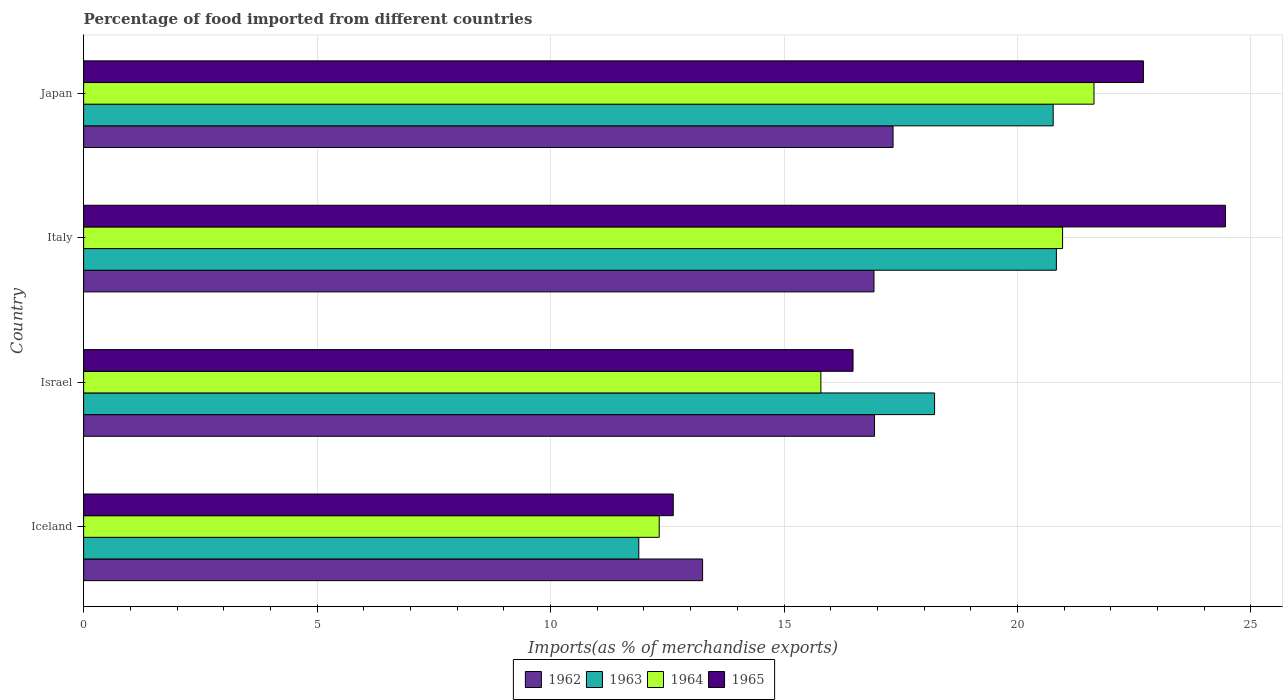How many different coloured bars are there?
Your answer should be compact. 4. How many groups of bars are there?
Provide a short and direct response. 4. Are the number of bars on each tick of the Y-axis equal?
Keep it short and to the point. Yes. How many bars are there on the 2nd tick from the top?
Your response must be concise. 4. How many bars are there on the 3rd tick from the bottom?
Give a very brief answer. 4. What is the percentage of imports to different countries in 1962 in Japan?
Provide a short and direct response. 17.34. Across all countries, what is the maximum percentage of imports to different countries in 1964?
Provide a short and direct response. 21.64. Across all countries, what is the minimum percentage of imports to different countries in 1965?
Offer a very short reply. 12.63. In which country was the percentage of imports to different countries in 1963 maximum?
Your response must be concise. Italy. What is the total percentage of imports to different countries in 1963 in the graph?
Your answer should be very brief. 71.71. What is the difference between the percentage of imports to different countries in 1963 in Italy and that in Japan?
Your response must be concise. 0.07. What is the difference between the percentage of imports to different countries in 1962 in Italy and the percentage of imports to different countries in 1963 in Iceland?
Your response must be concise. 5.04. What is the average percentage of imports to different countries in 1962 per country?
Make the answer very short. 16.11. What is the difference between the percentage of imports to different countries in 1964 and percentage of imports to different countries in 1963 in Italy?
Offer a very short reply. 0.13. What is the ratio of the percentage of imports to different countries in 1965 in Israel to that in Italy?
Provide a short and direct response. 0.67. Is the percentage of imports to different countries in 1962 in Iceland less than that in Israel?
Your response must be concise. Yes. What is the difference between the highest and the second highest percentage of imports to different countries in 1965?
Offer a very short reply. 1.76. What is the difference between the highest and the lowest percentage of imports to different countries in 1965?
Your answer should be compact. 11.83. Is the sum of the percentage of imports to different countries in 1964 in Iceland and Japan greater than the maximum percentage of imports to different countries in 1963 across all countries?
Your answer should be compact. Yes. What does the 4th bar from the top in Italy represents?
Offer a terse response. 1962. What does the 3rd bar from the bottom in Italy represents?
Your answer should be compact. 1964. Does the graph contain any zero values?
Ensure brevity in your answer.  No. Does the graph contain grids?
Your answer should be compact. Yes. How many legend labels are there?
Offer a terse response. 4. How are the legend labels stacked?
Your answer should be compact. Horizontal. What is the title of the graph?
Provide a short and direct response. Percentage of food imported from different countries. What is the label or title of the X-axis?
Ensure brevity in your answer.  Imports(as % of merchandise exports). What is the Imports(as % of merchandise exports) of 1962 in Iceland?
Give a very brief answer. 13.26. What is the Imports(as % of merchandise exports) of 1963 in Iceland?
Offer a very short reply. 11.89. What is the Imports(as % of merchandise exports) in 1964 in Iceland?
Provide a succinct answer. 12.33. What is the Imports(as % of merchandise exports) in 1965 in Iceland?
Make the answer very short. 12.63. What is the Imports(as % of merchandise exports) in 1962 in Israel?
Give a very brief answer. 16.94. What is the Imports(as % of merchandise exports) in 1963 in Israel?
Offer a terse response. 18.22. What is the Imports(as % of merchandise exports) in 1964 in Israel?
Offer a very short reply. 15.79. What is the Imports(as % of merchandise exports) of 1965 in Israel?
Provide a short and direct response. 16.48. What is the Imports(as % of merchandise exports) of 1962 in Italy?
Provide a short and direct response. 16.93. What is the Imports(as % of merchandise exports) of 1963 in Italy?
Your answer should be compact. 20.83. What is the Imports(as % of merchandise exports) of 1964 in Italy?
Your answer should be very brief. 20.97. What is the Imports(as % of merchandise exports) of 1965 in Italy?
Provide a short and direct response. 24.45. What is the Imports(as % of merchandise exports) of 1962 in Japan?
Ensure brevity in your answer.  17.34. What is the Imports(as % of merchandise exports) of 1963 in Japan?
Ensure brevity in your answer.  20.76. What is the Imports(as % of merchandise exports) in 1964 in Japan?
Keep it short and to the point. 21.64. What is the Imports(as % of merchandise exports) in 1965 in Japan?
Give a very brief answer. 22.7. Across all countries, what is the maximum Imports(as % of merchandise exports) in 1962?
Make the answer very short. 17.34. Across all countries, what is the maximum Imports(as % of merchandise exports) in 1963?
Keep it short and to the point. 20.83. Across all countries, what is the maximum Imports(as % of merchandise exports) in 1964?
Keep it short and to the point. 21.64. Across all countries, what is the maximum Imports(as % of merchandise exports) of 1965?
Your answer should be very brief. 24.45. Across all countries, what is the minimum Imports(as % of merchandise exports) of 1962?
Your response must be concise. 13.26. Across all countries, what is the minimum Imports(as % of merchandise exports) in 1963?
Offer a terse response. 11.89. Across all countries, what is the minimum Imports(as % of merchandise exports) in 1964?
Provide a short and direct response. 12.33. Across all countries, what is the minimum Imports(as % of merchandise exports) of 1965?
Your response must be concise. 12.63. What is the total Imports(as % of merchandise exports) of 1962 in the graph?
Offer a very short reply. 64.46. What is the total Imports(as % of merchandise exports) of 1963 in the graph?
Make the answer very short. 71.71. What is the total Imports(as % of merchandise exports) in 1964 in the graph?
Offer a very short reply. 70.72. What is the total Imports(as % of merchandise exports) of 1965 in the graph?
Ensure brevity in your answer.  76.25. What is the difference between the Imports(as % of merchandise exports) in 1962 in Iceland and that in Israel?
Give a very brief answer. -3.68. What is the difference between the Imports(as % of merchandise exports) of 1963 in Iceland and that in Israel?
Offer a terse response. -6.33. What is the difference between the Imports(as % of merchandise exports) in 1964 in Iceland and that in Israel?
Your answer should be compact. -3.46. What is the difference between the Imports(as % of merchandise exports) of 1965 in Iceland and that in Israel?
Provide a short and direct response. -3.85. What is the difference between the Imports(as % of merchandise exports) in 1962 in Iceland and that in Italy?
Your answer should be very brief. -3.67. What is the difference between the Imports(as % of merchandise exports) of 1963 in Iceland and that in Italy?
Offer a terse response. -8.94. What is the difference between the Imports(as % of merchandise exports) of 1964 in Iceland and that in Italy?
Provide a short and direct response. -8.64. What is the difference between the Imports(as % of merchandise exports) of 1965 in Iceland and that in Italy?
Ensure brevity in your answer.  -11.82. What is the difference between the Imports(as % of merchandise exports) in 1962 in Iceland and that in Japan?
Your response must be concise. -4.08. What is the difference between the Imports(as % of merchandise exports) in 1963 in Iceland and that in Japan?
Provide a succinct answer. -8.87. What is the difference between the Imports(as % of merchandise exports) in 1964 in Iceland and that in Japan?
Offer a terse response. -9.31. What is the difference between the Imports(as % of merchandise exports) of 1965 in Iceland and that in Japan?
Ensure brevity in your answer.  -10.07. What is the difference between the Imports(as % of merchandise exports) in 1962 in Israel and that in Italy?
Provide a short and direct response. 0.01. What is the difference between the Imports(as % of merchandise exports) of 1963 in Israel and that in Italy?
Make the answer very short. -2.61. What is the difference between the Imports(as % of merchandise exports) in 1964 in Israel and that in Italy?
Provide a short and direct response. -5.18. What is the difference between the Imports(as % of merchandise exports) in 1965 in Israel and that in Italy?
Make the answer very short. -7.97. What is the difference between the Imports(as % of merchandise exports) in 1962 in Israel and that in Japan?
Your answer should be very brief. -0.4. What is the difference between the Imports(as % of merchandise exports) of 1963 in Israel and that in Japan?
Offer a terse response. -2.54. What is the difference between the Imports(as % of merchandise exports) in 1964 in Israel and that in Japan?
Your answer should be very brief. -5.85. What is the difference between the Imports(as % of merchandise exports) in 1965 in Israel and that in Japan?
Ensure brevity in your answer.  -6.22. What is the difference between the Imports(as % of merchandise exports) in 1962 in Italy and that in Japan?
Provide a succinct answer. -0.41. What is the difference between the Imports(as % of merchandise exports) in 1963 in Italy and that in Japan?
Offer a very short reply. 0.07. What is the difference between the Imports(as % of merchandise exports) of 1964 in Italy and that in Japan?
Ensure brevity in your answer.  -0.67. What is the difference between the Imports(as % of merchandise exports) in 1965 in Italy and that in Japan?
Give a very brief answer. 1.76. What is the difference between the Imports(as % of merchandise exports) in 1962 in Iceland and the Imports(as % of merchandise exports) in 1963 in Israel?
Give a very brief answer. -4.97. What is the difference between the Imports(as % of merchandise exports) of 1962 in Iceland and the Imports(as % of merchandise exports) of 1964 in Israel?
Provide a succinct answer. -2.53. What is the difference between the Imports(as % of merchandise exports) of 1962 in Iceland and the Imports(as % of merchandise exports) of 1965 in Israel?
Offer a very short reply. -3.22. What is the difference between the Imports(as % of merchandise exports) in 1963 in Iceland and the Imports(as % of merchandise exports) in 1964 in Israel?
Provide a succinct answer. -3.9. What is the difference between the Imports(as % of merchandise exports) in 1963 in Iceland and the Imports(as % of merchandise exports) in 1965 in Israel?
Make the answer very short. -4.59. What is the difference between the Imports(as % of merchandise exports) of 1964 in Iceland and the Imports(as % of merchandise exports) of 1965 in Israel?
Ensure brevity in your answer.  -4.15. What is the difference between the Imports(as % of merchandise exports) in 1962 in Iceland and the Imports(as % of merchandise exports) in 1963 in Italy?
Your answer should be compact. -7.58. What is the difference between the Imports(as % of merchandise exports) of 1962 in Iceland and the Imports(as % of merchandise exports) of 1964 in Italy?
Provide a succinct answer. -7.71. What is the difference between the Imports(as % of merchandise exports) in 1962 in Iceland and the Imports(as % of merchandise exports) in 1965 in Italy?
Your answer should be very brief. -11.2. What is the difference between the Imports(as % of merchandise exports) in 1963 in Iceland and the Imports(as % of merchandise exports) in 1964 in Italy?
Your answer should be very brief. -9.08. What is the difference between the Imports(as % of merchandise exports) in 1963 in Iceland and the Imports(as % of merchandise exports) in 1965 in Italy?
Keep it short and to the point. -12.56. What is the difference between the Imports(as % of merchandise exports) in 1964 in Iceland and the Imports(as % of merchandise exports) in 1965 in Italy?
Provide a short and direct response. -12.13. What is the difference between the Imports(as % of merchandise exports) of 1962 in Iceland and the Imports(as % of merchandise exports) of 1963 in Japan?
Provide a short and direct response. -7.51. What is the difference between the Imports(as % of merchandise exports) of 1962 in Iceland and the Imports(as % of merchandise exports) of 1964 in Japan?
Offer a terse response. -8.38. What is the difference between the Imports(as % of merchandise exports) in 1962 in Iceland and the Imports(as % of merchandise exports) in 1965 in Japan?
Provide a succinct answer. -9.44. What is the difference between the Imports(as % of merchandise exports) of 1963 in Iceland and the Imports(as % of merchandise exports) of 1964 in Japan?
Keep it short and to the point. -9.75. What is the difference between the Imports(as % of merchandise exports) of 1963 in Iceland and the Imports(as % of merchandise exports) of 1965 in Japan?
Ensure brevity in your answer.  -10.81. What is the difference between the Imports(as % of merchandise exports) of 1964 in Iceland and the Imports(as % of merchandise exports) of 1965 in Japan?
Your response must be concise. -10.37. What is the difference between the Imports(as % of merchandise exports) of 1962 in Israel and the Imports(as % of merchandise exports) of 1963 in Italy?
Ensure brevity in your answer.  -3.89. What is the difference between the Imports(as % of merchandise exports) of 1962 in Israel and the Imports(as % of merchandise exports) of 1964 in Italy?
Make the answer very short. -4.03. What is the difference between the Imports(as % of merchandise exports) in 1962 in Israel and the Imports(as % of merchandise exports) in 1965 in Italy?
Offer a terse response. -7.51. What is the difference between the Imports(as % of merchandise exports) in 1963 in Israel and the Imports(as % of merchandise exports) in 1964 in Italy?
Your answer should be compact. -2.74. What is the difference between the Imports(as % of merchandise exports) of 1963 in Israel and the Imports(as % of merchandise exports) of 1965 in Italy?
Make the answer very short. -6.23. What is the difference between the Imports(as % of merchandise exports) of 1964 in Israel and the Imports(as % of merchandise exports) of 1965 in Italy?
Offer a very short reply. -8.66. What is the difference between the Imports(as % of merchandise exports) of 1962 in Israel and the Imports(as % of merchandise exports) of 1963 in Japan?
Provide a short and direct response. -3.83. What is the difference between the Imports(as % of merchandise exports) of 1962 in Israel and the Imports(as % of merchandise exports) of 1964 in Japan?
Your answer should be very brief. -4.7. What is the difference between the Imports(as % of merchandise exports) in 1962 in Israel and the Imports(as % of merchandise exports) in 1965 in Japan?
Ensure brevity in your answer.  -5.76. What is the difference between the Imports(as % of merchandise exports) in 1963 in Israel and the Imports(as % of merchandise exports) in 1964 in Japan?
Your response must be concise. -3.41. What is the difference between the Imports(as % of merchandise exports) of 1963 in Israel and the Imports(as % of merchandise exports) of 1965 in Japan?
Your answer should be very brief. -4.47. What is the difference between the Imports(as % of merchandise exports) of 1964 in Israel and the Imports(as % of merchandise exports) of 1965 in Japan?
Your response must be concise. -6.91. What is the difference between the Imports(as % of merchandise exports) of 1962 in Italy and the Imports(as % of merchandise exports) of 1963 in Japan?
Offer a very short reply. -3.84. What is the difference between the Imports(as % of merchandise exports) in 1962 in Italy and the Imports(as % of merchandise exports) in 1964 in Japan?
Offer a very short reply. -4.71. What is the difference between the Imports(as % of merchandise exports) in 1962 in Italy and the Imports(as % of merchandise exports) in 1965 in Japan?
Keep it short and to the point. -5.77. What is the difference between the Imports(as % of merchandise exports) in 1963 in Italy and the Imports(as % of merchandise exports) in 1964 in Japan?
Ensure brevity in your answer.  -0.81. What is the difference between the Imports(as % of merchandise exports) of 1963 in Italy and the Imports(as % of merchandise exports) of 1965 in Japan?
Provide a short and direct response. -1.86. What is the difference between the Imports(as % of merchandise exports) in 1964 in Italy and the Imports(as % of merchandise exports) in 1965 in Japan?
Provide a succinct answer. -1.73. What is the average Imports(as % of merchandise exports) of 1962 per country?
Provide a short and direct response. 16.11. What is the average Imports(as % of merchandise exports) of 1963 per country?
Keep it short and to the point. 17.93. What is the average Imports(as % of merchandise exports) in 1964 per country?
Make the answer very short. 17.68. What is the average Imports(as % of merchandise exports) in 1965 per country?
Ensure brevity in your answer.  19.06. What is the difference between the Imports(as % of merchandise exports) in 1962 and Imports(as % of merchandise exports) in 1963 in Iceland?
Make the answer very short. 1.37. What is the difference between the Imports(as % of merchandise exports) in 1962 and Imports(as % of merchandise exports) in 1964 in Iceland?
Provide a succinct answer. 0.93. What is the difference between the Imports(as % of merchandise exports) of 1962 and Imports(as % of merchandise exports) of 1965 in Iceland?
Give a very brief answer. 0.63. What is the difference between the Imports(as % of merchandise exports) in 1963 and Imports(as % of merchandise exports) in 1964 in Iceland?
Your response must be concise. -0.44. What is the difference between the Imports(as % of merchandise exports) of 1963 and Imports(as % of merchandise exports) of 1965 in Iceland?
Offer a very short reply. -0.74. What is the difference between the Imports(as % of merchandise exports) of 1964 and Imports(as % of merchandise exports) of 1965 in Iceland?
Your answer should be very brief. -0.3. What is the difference between the Imports(as % of merchandise exports) in 1962 and Imports(as % of merchandise exports) in 1963 in Israel?
Offer a terse response. -1.29. What is the difference between the Imports(as % of merchandise exports) of 1962 and Imports(as % of merchandise exports) of 1964 in Israel?
Ensure brevity in your answer.  1.15. What is the difference between the Imports(as % of merchandise exports) of 1962 and Imports(as % of merchandise exports) of 1965 in Israel?
Your answer should be very brief. 0.46. What is the difference between the Imports(as % of merchandise exports) in 1963 and Imports(as % of merchandise exports) in 1964 in Israel?
Your response must be concise. 2.43. What is the difference between the Imports(as % of merchandise exports) in 1963 and Imports(as % of merchandise exports) in 1965 in Israel?
Give a very brief answer. 1.75. What is the difference between the Imports(as % of merchandise exports) of 1964 and Imports(as % of merchandise exports) of 1965 in Israel?
Give a very brief answer. -0.69. What is the difference between the Imports(as % of merchandise exports) in 1962 and Imports(as % of merchandise exports) in 1963 in Italy?
Make the answer very short. -3.91. What is the difference between the Imports(as % of merchandise exports) in 1962 and Imports(as % of merchandise exports) in 1964 in Italy?
Provide a succinct answer. -4.04. What is the difference between the Imports(as % of merchandise exports) of 1962 and Imports(as % of merchandise exports) of 1965 in Italy?
Give a very brief answer. -7.53. What is the difference between the Imports(as % of merchandise exports) in 1963 and Imports(as % of merchandise exports) in 1964 in Italy?
Make the answer very short. -0.13. What is the difference between the Imports(as % of merchandise exports) in 1963 and Imports(as % of merchandise exports) in 1965 in Italy?
Provide a succinct answer. -3.62. What is the difference between the Imports(as % of merchandise exports) of 1964 and Imports(as % of merchandise exports) of 1965 in Italy?
Provide a short and direct response. -3.49. What is the difference between the Imports(as % of merchandise exports) in 1962 and Imports(as % of merchandise exports) in 1963 in Japan?
Ensure brevity in your answer.  -3.43. What is the difference between the Imports(as % of merchandise exports) of 1962 and Imports(as % of merchandise exports) of 1964 in Japan?
Your response must be concise. -4.3. What is the difference between the Imports(as % of merchandise exports) of 1962 and Imports(as % of merchandise exports) of 1965 in Japan?
Provide a succinct answer. -5.36. What is the difference between the Imports(as % of merchandise exports) of 1963 and Imports(as % of merchandise exports) of 1964 in Japan?
Your response must be concise. -0.87. What is the difference between the Imports(as % of merchandise exports) in 1963 and Imports(as % of merchandise exports) in 1965 in Japan?
Make the answer very short. -1.93. What is the difference between the Imports(as % of merchandise exports) of 1964 and Imports(as % of merchandise exports) of 1965 in Japan?
Your response must be concise. -1.06. What is the ratio of the Imports(as % of merchandise exports) in 1962 in Iceland to that in Israel?
Ensure brevity in your answer.  0.78. What is the ratio of the Imports(as % of merchandise exports) in 1963 in Iceland to that in Israel?
Give a very brief answer. 0.65. What is the ratio of the Imports(as % of merchandise exports) of 1964 in Iceland to that in Israel?
Keep it short and to the point. 0.78. What is the ratio of the Imports(as % of merchandise exports) in 1965 in Iceland to that in Israel?
Make the answer very short. 0.77. What is the ratio of the Imports(as % of merchandise exports) of 1962 in Iceland to that in Italy?
Make the answer very short. 0.78. What is the ratio of the Imports(as % of merchandise exports) in 1963 in Iceland to that in Italy?
Offer a terse response. 0.57. What is the ratio of the Imports(as % of merchandise exports) in 1964 in Iceland to that in Italy?
Keep it short and to the point. 0.59. What is the ratio of the Imports(as % of merchandise exports) of 1965 in Iceland to that in Italy?
Make the answer very short. 0.52. What is the ratio of the Imports(as % of merchandise exports) in 1962 in Iceland to that in Japan?
Your answer should be compact. 0.76. What is the ratio of the Imports(as % of merchandise exports) of 1963 in Iceland to that in Japan?
Your answer should be very brief. 0.57. What is the ratio of the Imports(as % of merchandise exports) of 1964 in Iceland to that in Japan?
Offer a very short reply. 0.57. What is the ratio of the Imports(as % of merchandise exports) in 1965 in Iceland to that in Japan?
Ensure brevity in your answer.  0.56. What is the ratio of the Imports(as % of merchandise exports) of 1963 in Israel to that in Italy?
Keep it short and to the point. 0.87. What is the ratio of the Imports(as % of merchandise exports) in 1964 in Israel to that in Italy?
Give a very brief answer. 0.75. What is the ratio of the Imports(as % of merchandise exports) in 1965 in Israel to that in Italy?
Offer a terse response. 0.67. What is the ratio of the Imports(as % of merchandise exports) in 1962 in Israel to that in Japan?
Ensure brevity in your answer.  0.98. What is the ratio of the Imports(as % of merchandise exports) of 1963 in Israel to that in Japan?
Your answer should be very brief. 0.88. What is the ratio of the Imports(as % of merchandise exports) of 1964 in Israel to that in Japan?
Your answer should be very brief. 0.73. What is the ratio of the Imports(as % of merchandise exports) in 1965 in Israel to that in Japan?
Provide a short and direct response. 0.73. What is the ratio of the Imports(as % of merchandise exports) in 1962 in Italy to that in Japan?
Your answer should be very brief. 0.98. What is the ratio of the Imports(as % of merchandise exports) in 1964 in Italy to that in Japan?
Keep it short and to the point. 0.97. What is the ratio of the Imports(as % of merchandise exports) of 1965 in Italy to that in Japan?
Your response must be concise. 1.08. What is the difference between the highest and the second highest Imports(as % of merchandise exports) of 1962?
Your answer should be compact. 0.4. What is the difference between the highest and the second highest Imports(as % of merchandise exports) in 1963?
Your answer should be compact. 0.07. What is the difference between the highest and the second highest Imports(as % of merchandise exports) of 1964?
Ensure brevity in your answer.  0.67. What is the difference between the highest and the second highest Imports(as % of merchandise exports) in 1965?
Provide a short and direct response. 1.76. What is the difference between the highest and the lowest Imports(as % of merchandise exports) of 1962?
Ensure brevity in your answer.  4.08. What is the difference between the highest and the lowest Imports(as % of merchandise exports) in 1963?
Provide a succinct answer. 8.94. What is the difference between the highest and the lowest Imports(as % of merchandise exports) in 1964?
Your answer should be compact. 9.31. What is the difference between the highest and the lowest Imports(as % of merchandise exports) in 1965?
Make the answer very short. 11.82. 